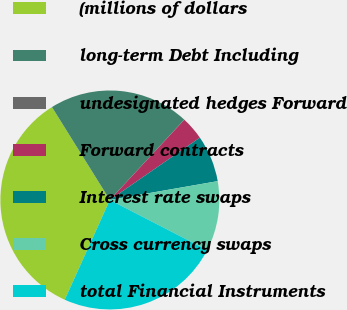<chart> <loc_0><loc_0><loc_500><loc_500><pie_chart><fcel>(millions of dollars<fcel>long-term Debt Including<fcel>undesignated hedges Forward<fcel>Forward contracts<fcel>Interest rate swaps<fcel>Cross currency swaps<fcel>total Financial Instruments<nl><fcel>34.37%<fcel>20.76%<fcel>0.02%<fcel>3.45%<fcel>6.89%<fcel>10.32%<fcel>24.19%<nl></chart> 